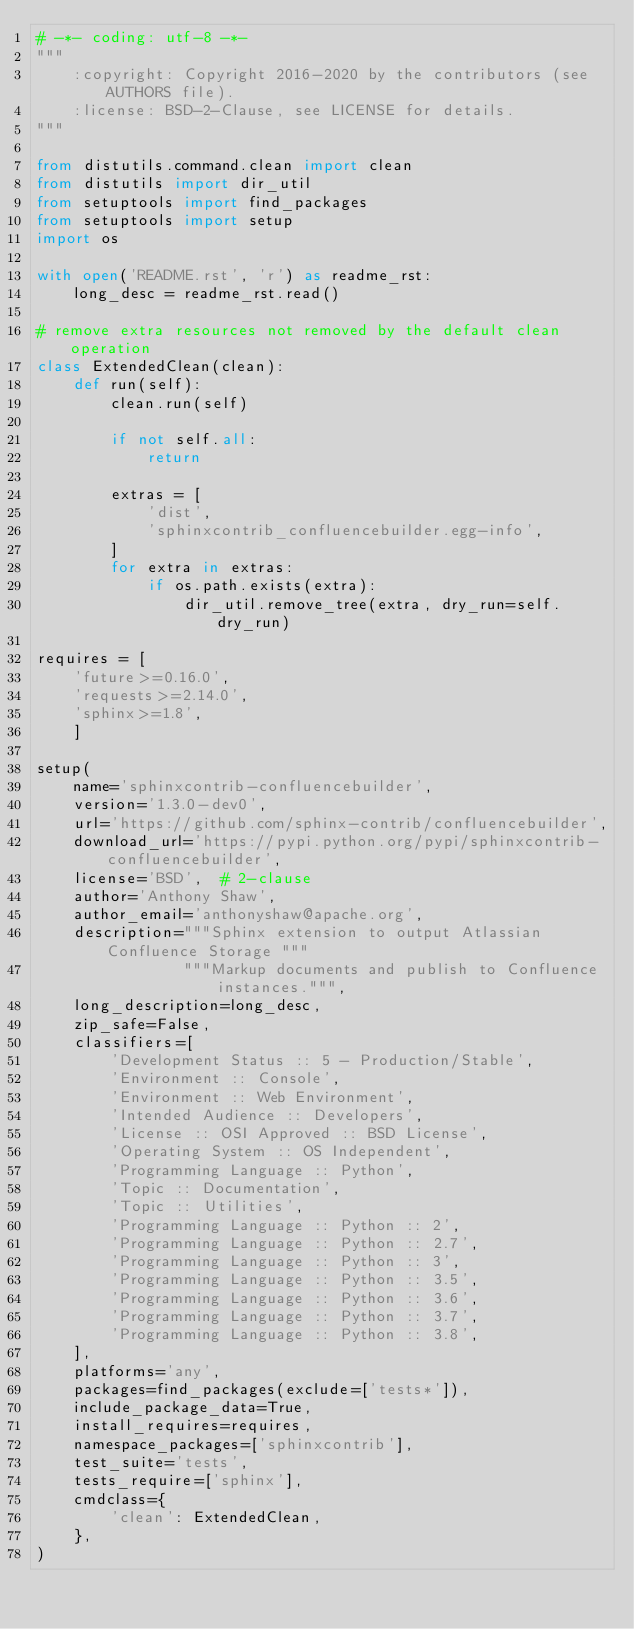<code> <loc_0><loc_0><loc_500><loc_500><_Python_># -*- coding: utf-8 -*-
"""
    :copyright: Copyright 2016-2020 by the contributors (see AUTHORS file).
    :license: BSD-2-Clause, see LICENSE for details.
"""

from distutils.command.clean import clean
from distutils import dir_util
from setuptools import find_packages
from setuptools import setup
import os

with open('README.rst', 'r') as readme_rst:
    long_desc = readme_rst.read()

# remove extra resources not removed by the default clean operation
class ExtendedClean(clean):
    def run(self):
        clean.run(self)

        if not self.all:
            return

        extras = [
            'dist',
            'sphinxcontrib_confluencebuilder.egg-info',
        ]
        for extra in extras:
            if os.path.exists(extra):
                dir_util.remove_tree(extra, dry_run=self.dry_run)

requires = [
    'future>=0.16.0',
    'requests>=2.14.0',
    'sphinx>=1.8',
    ]

setup(
    name='sphinxcontrib-confluencebuilder',
    version='1.3.0-dev0',
    url='https://github.com/sphinx-contrib/confluencebuilder',
    download_url='https://pypi.python.org/pypi/sphinxcontrib-confluencebuilder',
    license='BSD',  # 2-clause
    author='Anthony Shaw',
    author_email='anthonyshaw@apache.org',
    description="""Sphinx extension to output Atlassian Confluence Storage """
                """Markup documents and publish to Confluence instances.""",
    long_description=long_desc,
    zip_safe=False,
    classifiers=[
        'Development Status :: 5 - Production/Stable',
        'Environment :: Console',
        'Environment :: Web Environment',
        'Intended Audience :: Developers',
        'License :: OSI Approved :: BSD License',
        'Operating System :: OS Independent',
        'Programming Language :: Python',
        'Topic :: Documentation',
        'Topic :: Utilities',
        'Programming Language :: Python :: 2',
        'Programming Language :: Python :: 2.7',
        'Programming Language :: Python :: 3',
        'Programming Language :: Python :: 3.5',
        'Programming Language :: Python :: 3.6',
        'Programming Language :: Python :: 3.7',
        'Programming Language :: Python :: 3.8',
    ],
    platforms='any',
    packages=find_packages(exclude=['tests*']),
    include_package_data=True,
    install_requires=requires,
    namespace_packages=['sphinxcontrib'],
    test_suite='tests',
    tests_require=['sphinx'],
    cmdclass={
        'clean': ExtendedClean,
    },
)
</code> 